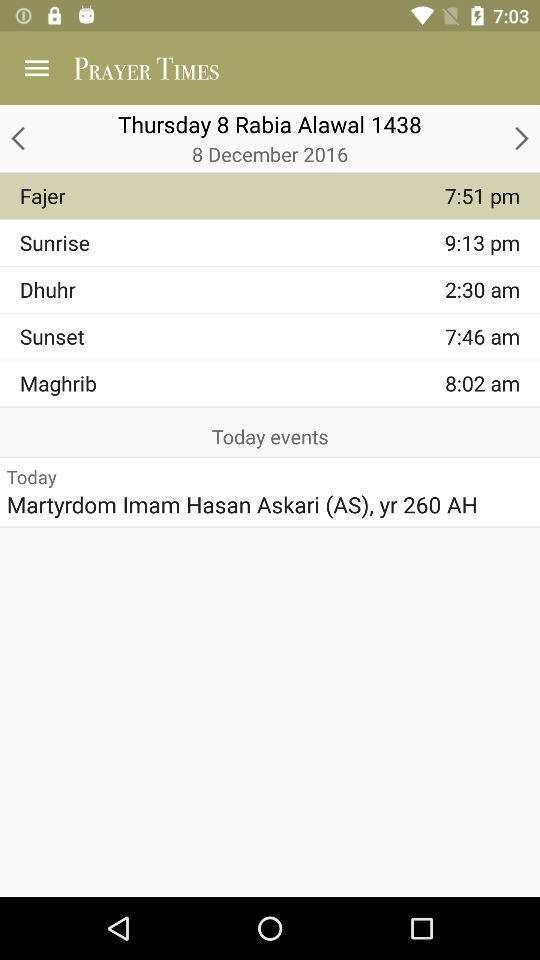What are the today's event? Today's event is "Martyrdom Imam Hasan Askari (AS), yr 260 AH". 